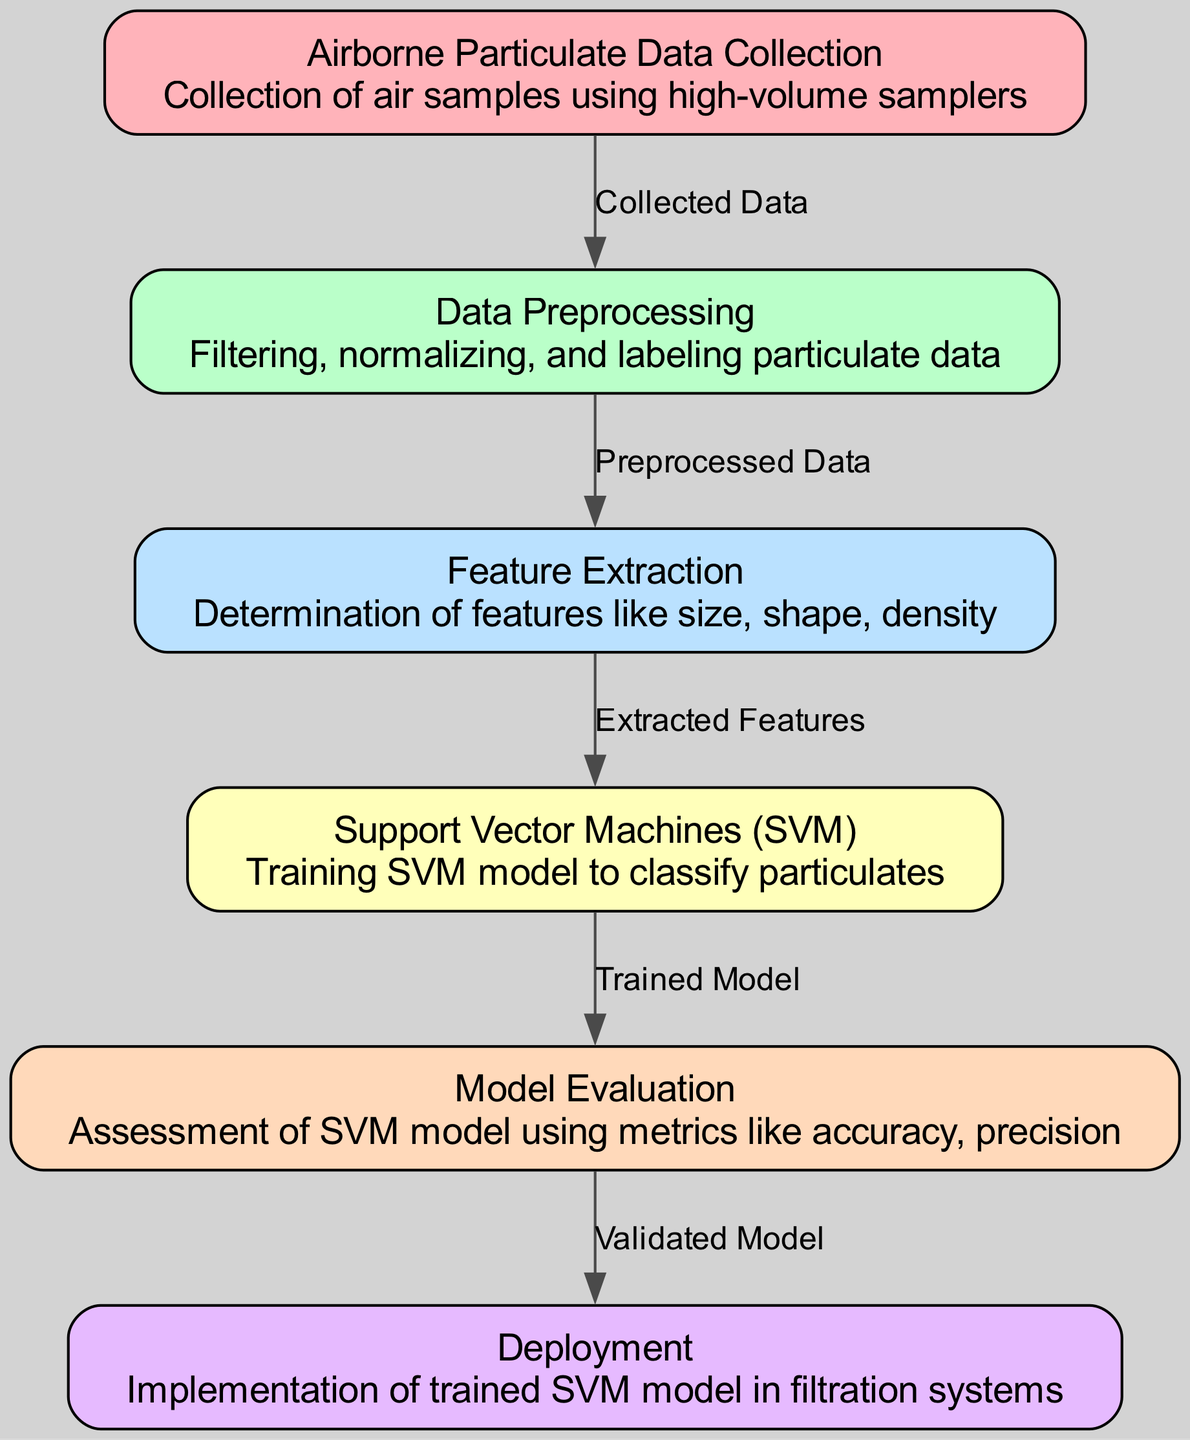What is the total number of nodes in the diagram? The diagram contains six distinct nodes that represent different stages of the classification process for airborne particulates. These are listed from data collection to deployment.
Answer: 6 What is the label of the node that represents the training model? The node that corresponds to the training model is labeled "Support Vector Machines (SVM)," which is a method used for classifying particulates.
Answer: Support Vector Machines (SVM) Which node comes immediately after "Data Preprocessing"? After the "Data Preprocessing" node, the next node is "Feature Extraction," which involves determining specific features of the particulate data.
Answer: Feature Extraction What type of edge connects "Model Evaluation" to "Deployment"? The edge connecting "Model Evaluation" to "Deployment" indicates that the model has been validated, which means the SVM model has passed assessment metrics such as accuracy and precision before implementation.
Answer: Validated Model How many edges are present in the diagram? The diagram has five edges that illustrate the relationships and flow of data from node to node throughout the classification process.
Answer: 5 What does the "Feature Extraction" node determine? The "Feature Extraction" node determines features such as size, shape, and density of the airborne particulates, which are critical for the classification process.
Answer: Features like size, shape, density Which step comes before the "Model Evaluation"? The step that precedes "Model Evaluation" is "Support Vector Machines (SVM)," where the model is trained using the extracted features of the particulate data collected.
Answer: Support Vector Machines (SVM) What is the primary output of the "Support Vector Machines (SVM)" node? The primary output of the "Support Vector Machines (SVM)" node is the trained model that can classify the airborne particulates based on the analyzed features.
Answer: Trained Model What is contained within the "Airborne Particulate Data Collection" node? The "Airborne Particulate Data Collection" node contains information about the collection of air samples, specifically using high-volume samplers to obtain the data.
Answer: Air samples using high-volume samplers 